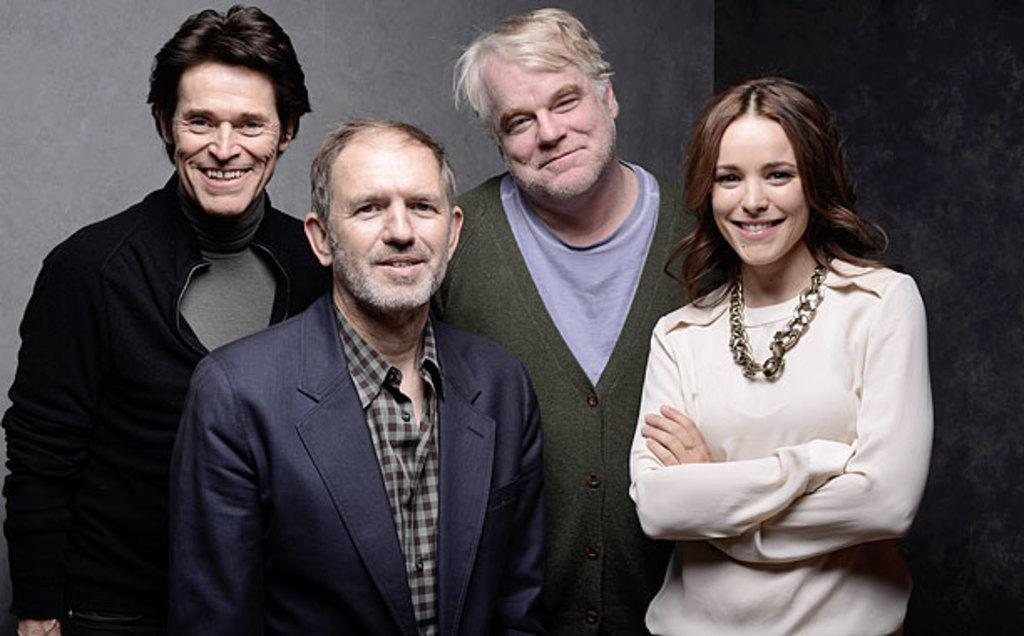What is the main subject of the image? The main subject of the image is a group of people. How are the people in the group depicted? All the people in the group are smiling. What type of crown is worn by the servant in the image? There is no servant or crown present in the image. 